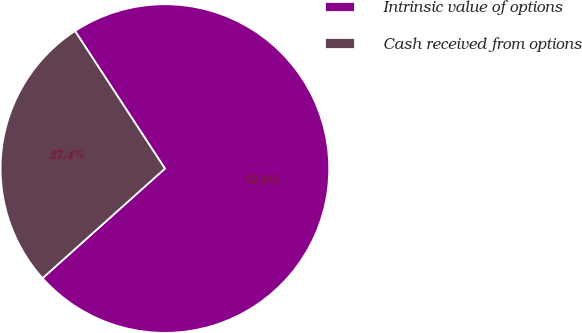Convert chart to OTSL. <chart><loc_0><loc_0><loc_500><loc_500><pie_chart><fcel>Intrinsic value of options<fcel>Cash received from options<nl><fcel>72.59%<fcel>27.41%<nl></chart> 